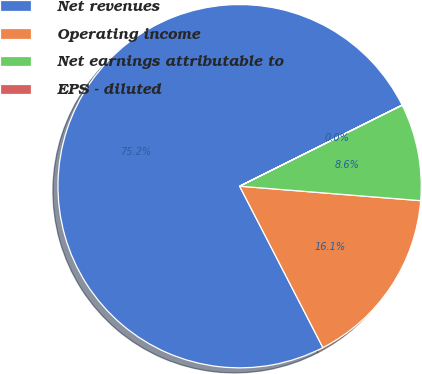Convert chart. <chart><loc_0><loc_0><loc_500><loc_500><pie_chart><fcel>Net revenues<fcel>Operating income<fcel>Net earnings attributable to<fcel>EPS - diluted<nl><fcel>75.22%<fcel>16.15%<fcel>8.63%<fcel>0.01%<nl></chart> 